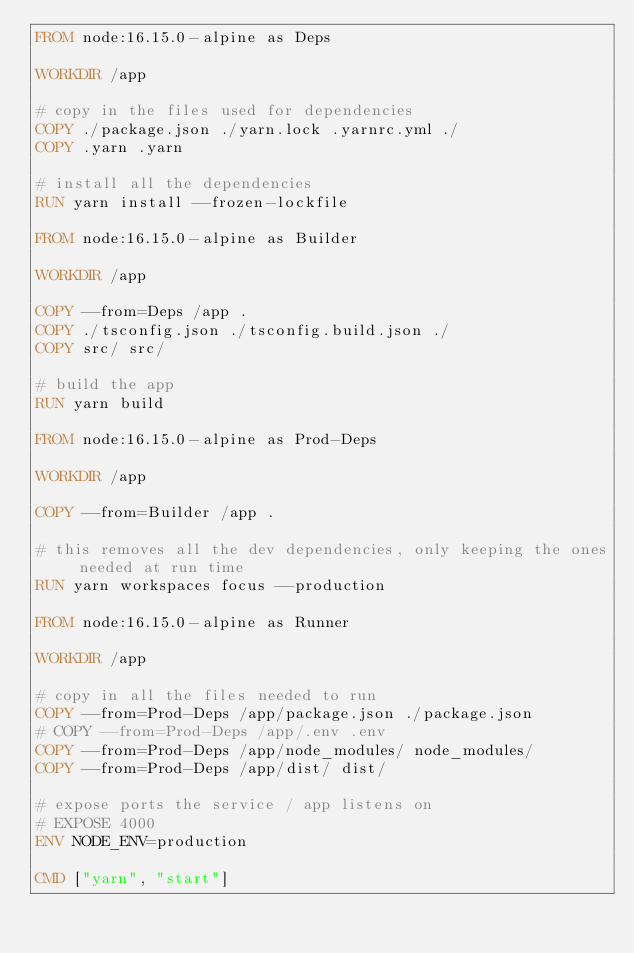<code> <loc_0><loc_0><loc_500><loc_500><_Dockerfile_>FROM node:16.15.0-alpine as Deps

WORKDIR /app

# copy in the files used for dependencies
COPY ./package.json ./yarn.lock .yarnrc.yml ./
COPY .yarn .yarn

# install all the dependencies
RUN yarn install --frozen-lockfile

FROM node:16.15.0-alpine as Builder

WORKDIR /app

COPY --from=Deps /app .
COPY ./tsconfig.json ./tsconfig.build.json ./
COPY src/ src/

# build the app
RUN yarn build

FROM node:16.15.0-alpine as Prod-Deps

WORKDIR /app

COPY --from=Builder /app .

# this removes all the dev dependencies, only keeping the ones needed at run time
RUN yarn workspaces focus --production

FROM node:16.15.0-alpine as Runner

WORKDIR /app

# copy in all the files needed to run
COPY --from=Prod-Deps /app/package.json ./package.json
# COPY --from=Prod-Deps /app/.env .env
COPY --from=Prod-Deps /app/node_modules/ node_modules/
COPY --from=Prod-Deps /app/dist/ dist/

# expose ports the service / app listens on
# EXPOSE 4000
ENV NODE_ENV=production

CMD ["yarn", "start"]</code> 